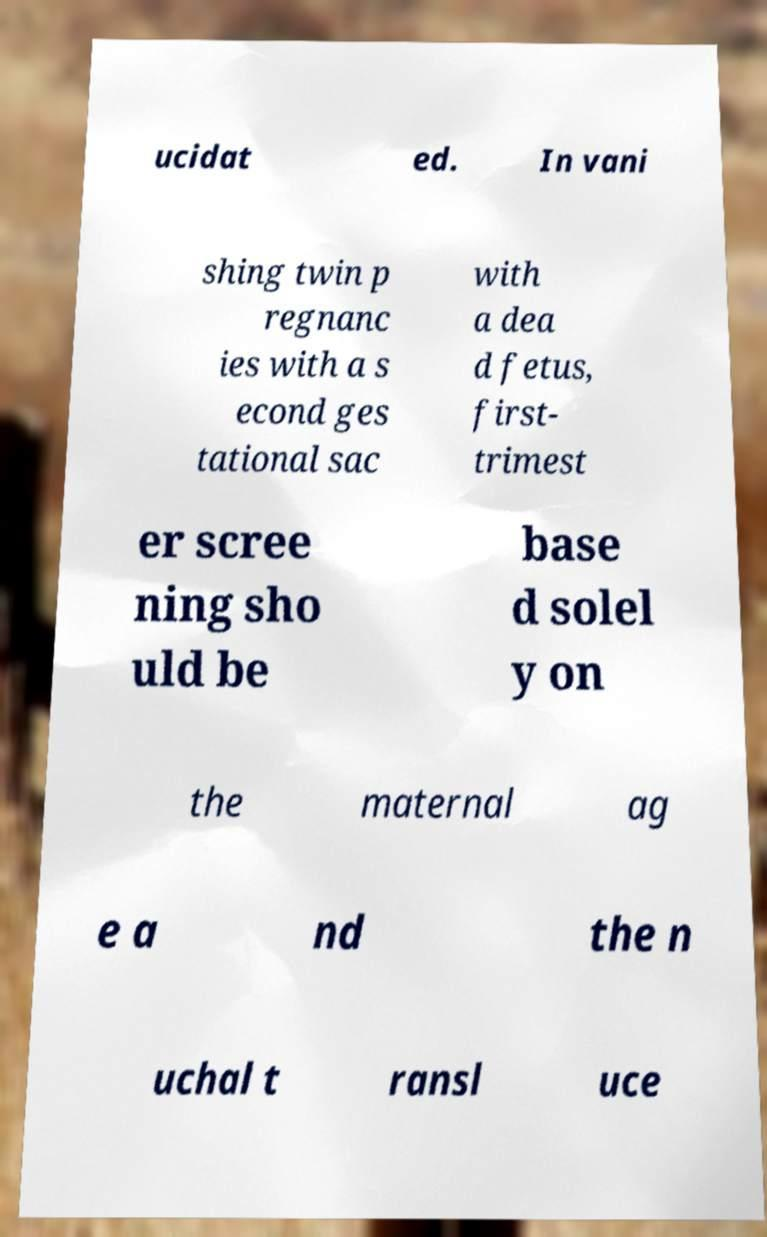For documentation purposes, I need the text within this image transcribed. Could you provide that? ucidat ed. In vani shing twin p regnanc ies with a s econd ges tational sac with a dea d fetus, first- trimest er scree ning sho uld be base d solel y on the maternal ag e a nd the n uchal t ransl uce 